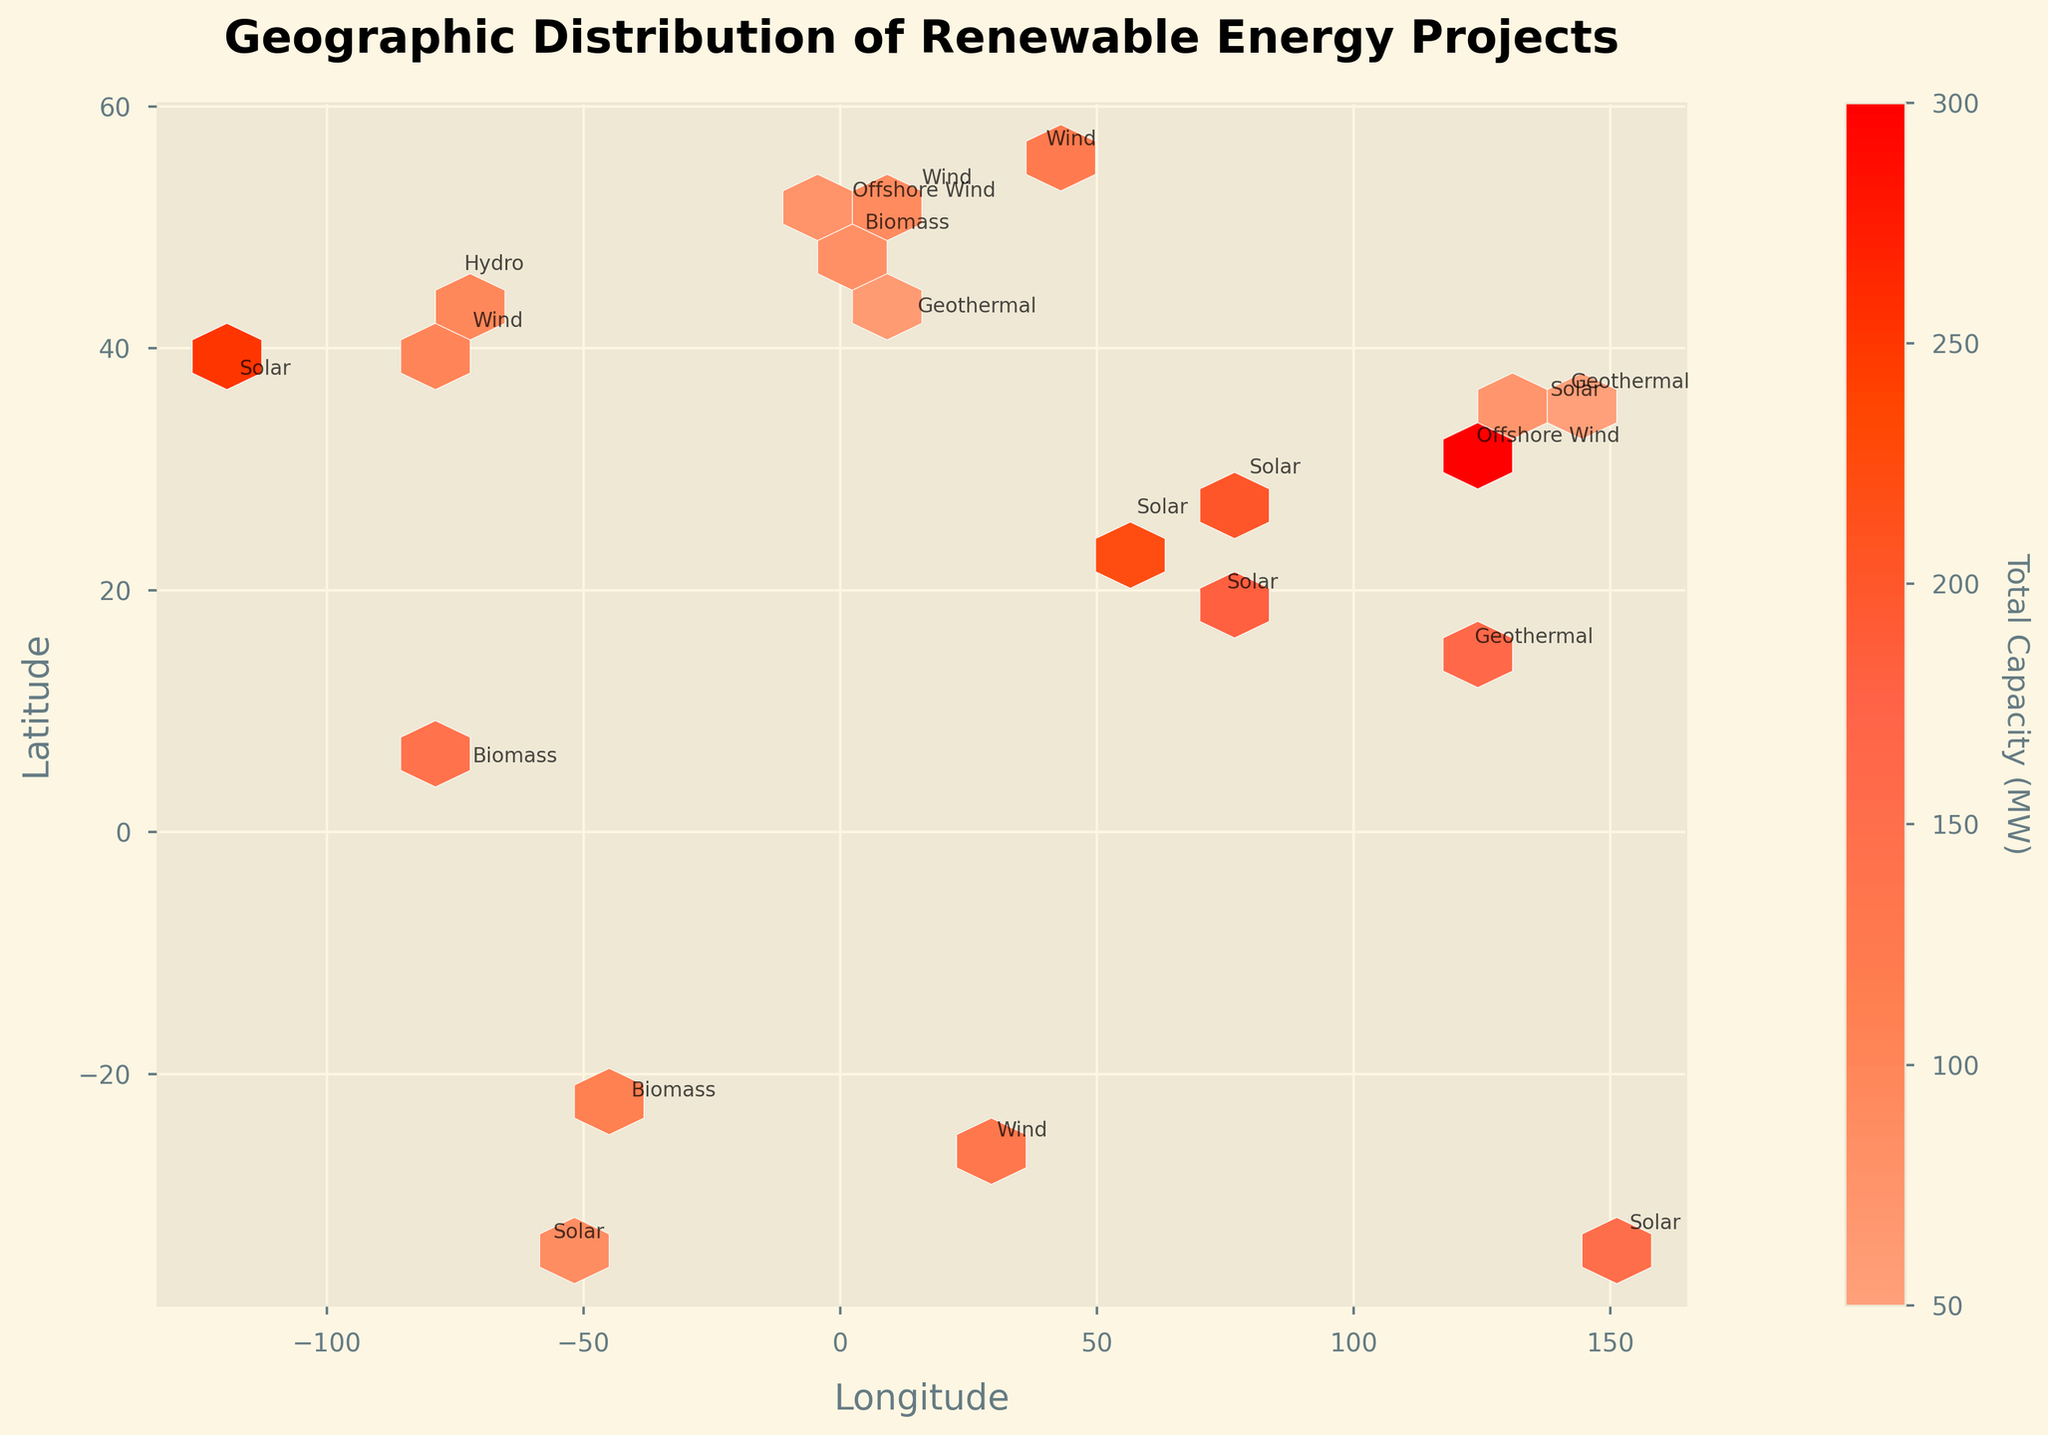What's the title of the figure? The title of the figure is displayed at the top and is centered, indicating the main focus of the plot.
Answer: Geographic Distribution of Renewable Energy Projects What do the colors in the hexagons represent? The color of the hexagons represents the total capacity of renewable energy projects in megawatts (MW). Darker colors indicate higher capacities.
Answer: Total Capacity (MW) How are the x-axis and y-axis labeled? The x-axis is labeled as "Longitude" and the y-axis is labeled as "Latitude." These labels help to position the geographic location of the renewable energy projects.
Answer: Longitude, Latitude What is the range of the hexbin grid size used in the plot? The hexbin grid size refers to the number of hexagons used to partition the plot area. By observing the density of hexagons across the plot, it is evident that the grid size spans various locations, typically covering a grid size of 20.
Answer: Gridsize 20 Which region appears to have the highest concentration of total capacity (MW) for renewable energy projects? By looking at the darker hexagons, which are the most concentrated in terms of color, one can identify the regions with higher total capacities. The darkest regions usually indicate higher outputs.
Answer: East Asia (around longitude 120-140) Which renewable energy project type seems to be most widely distributed globally? By observing the annotations that denote the types of projects spread across different geographic locations, we can infer which type is more prevalent worldwide.
Answer: Solar What is the latitude and longitude of the highest capacity solar project? Locate the hexagon with the highest color intensity and refer to its annotation to determine the latitude and longitude for the respective project type.
Answer: Latitude: 31.230391, Longitude: 121.473701 Compare the distribution of Solar and Wind projects. Which one has more diverse geographic coverage? Examine the extent to which "Solar" and "Wind" projects are annotated across various locations in the plot and compare their geographic distribution.
Answer: Wind Are there any renewable energy projects in South America, and if so, what type are they? Scan the plot for annotations within the geographical bounds of South America, specifically checking the coordinates relevant to that continent.
Answer: Biomass What appears to be the primary source of renewable energy in Europe based on the plot? By identifying the types of renewable energy projects annotated in the geographic region corresponding to Europe, one can infer the primary energy source.
Answer: Wind 